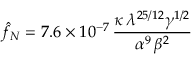<formula> <loc_0><loc_0><loc_500><loc_500>\hat { f } _ { N } = 7 . 6 \times 1 0 ^ { - 7 } \, \frac { \kappa \, \lambda ^ { 2 5 / 1 2 } \gamma ^ { 1 / 2 } } { \alpha ^ { 9 } \, \beta ^ { 2 } }</formula> 